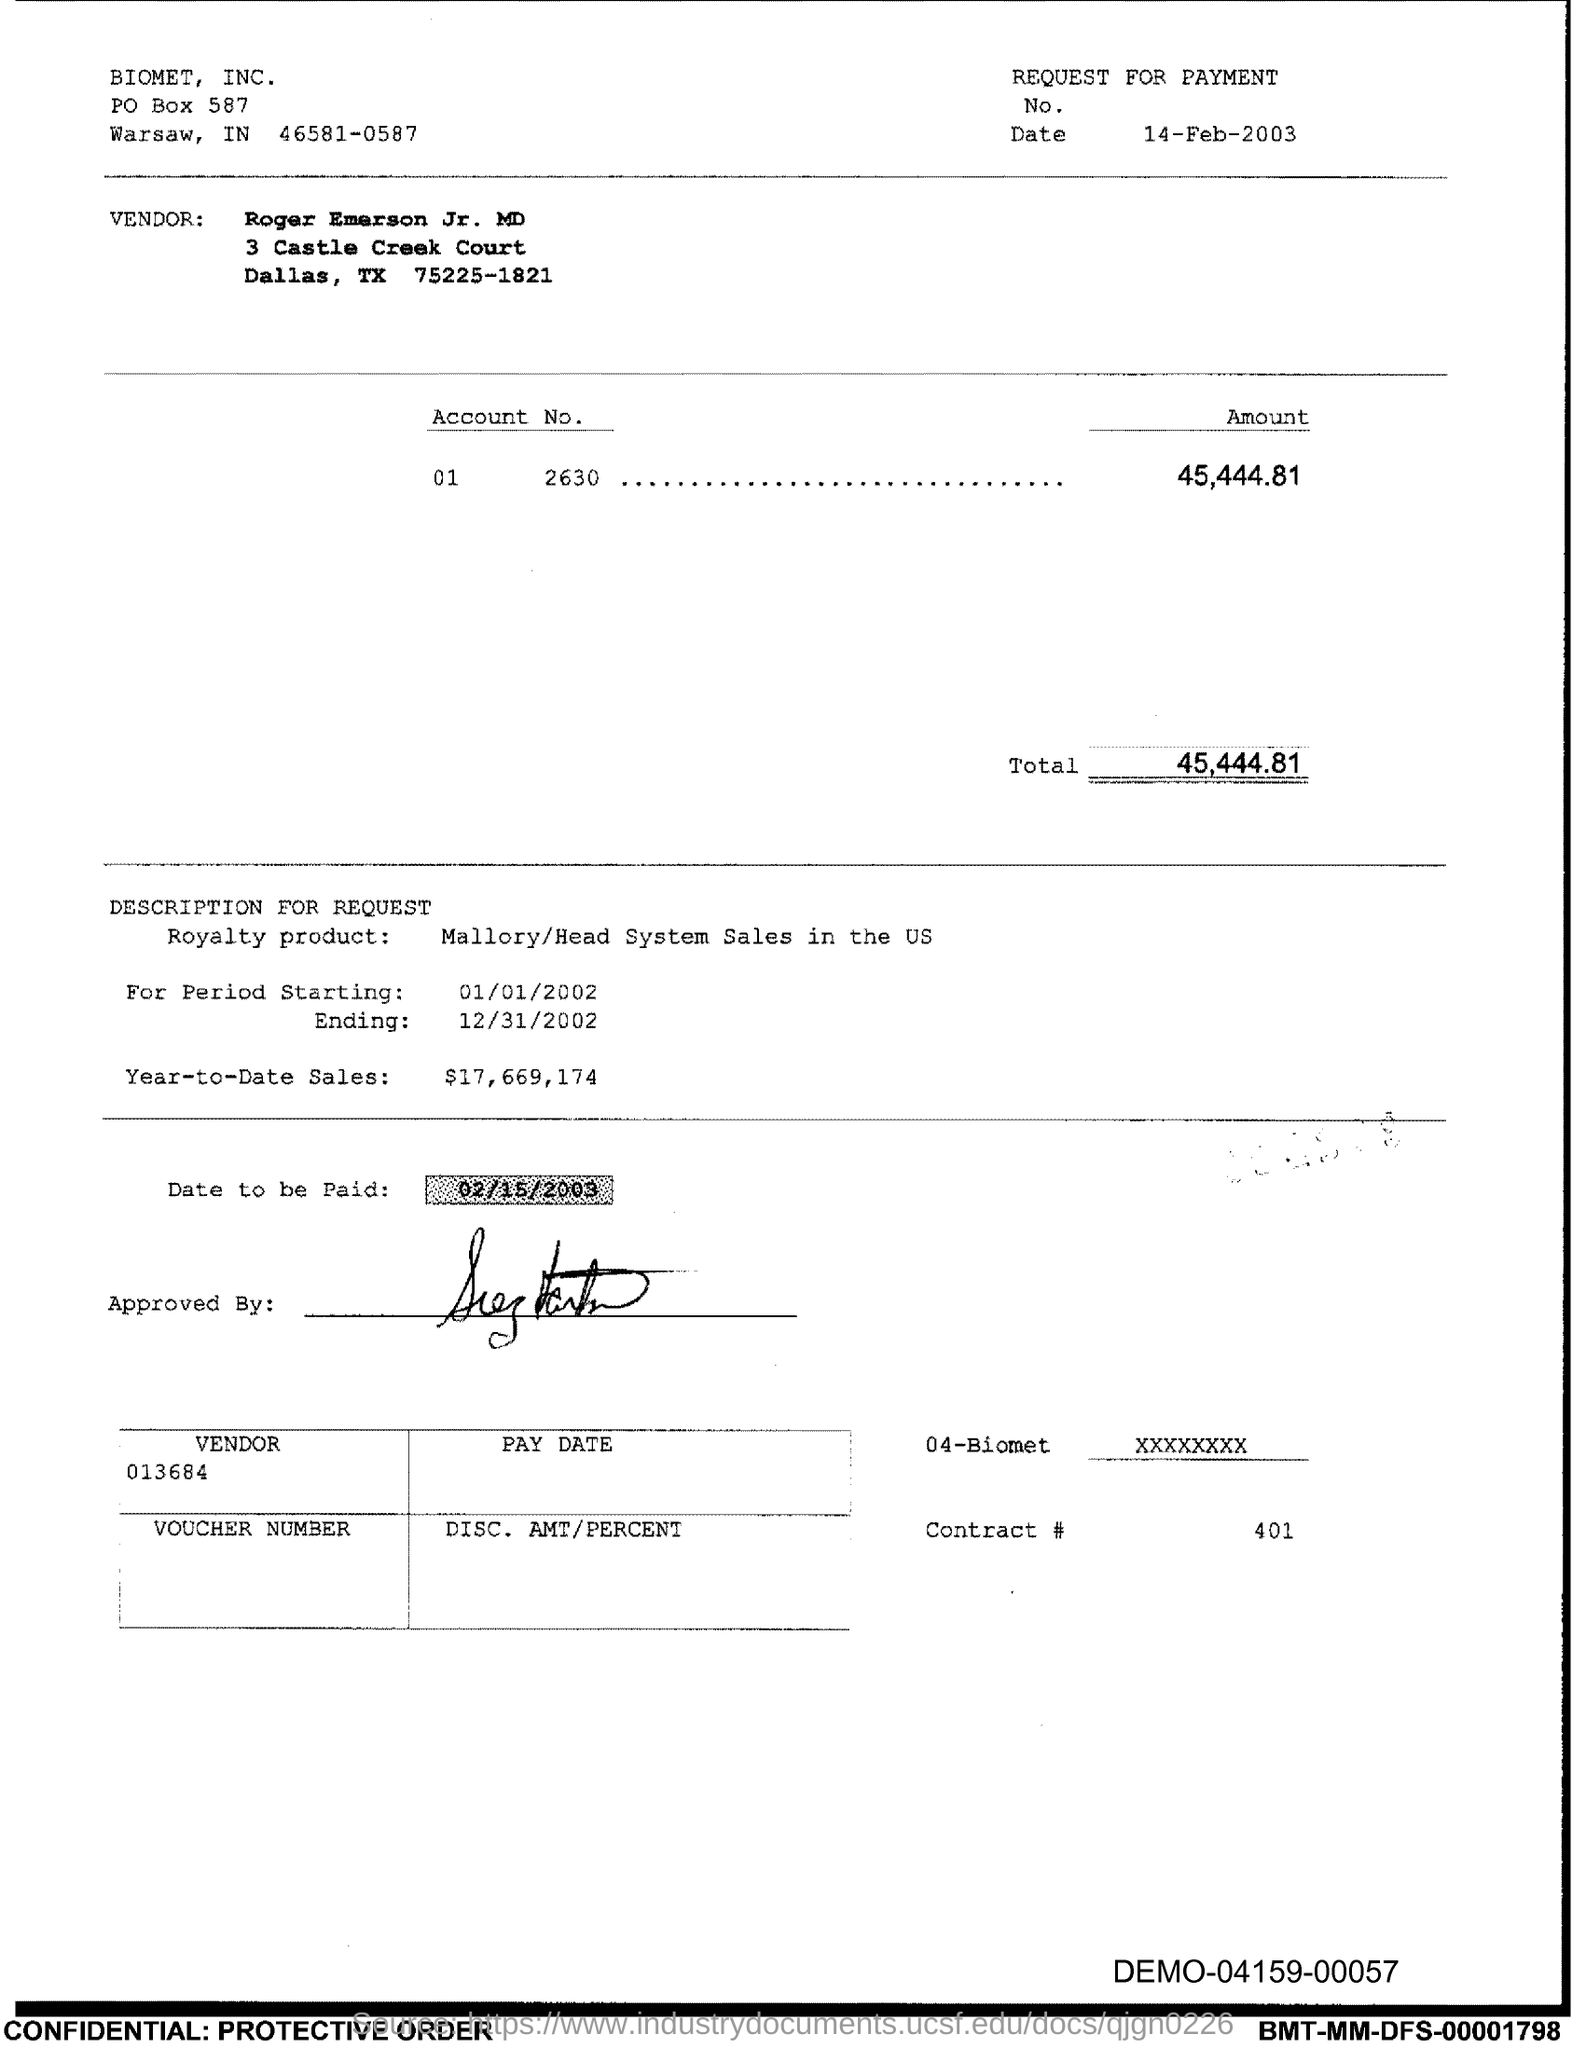Can you tell me the date this payment request was issued? The date on which the request for payment was issued is February 14, 2003, as noted at the top right of the document next to 'Date.' 